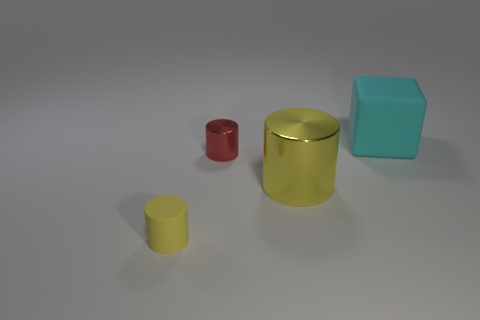Are there more tiny cylinders than objects?
Offer a very short reply. No. Is there anything else that has the same color as the small metallic thing?
Keep it short and to the point. No. Is the big cylinder made of the same material as the small red thing?
Make the answer very short. Yes. Is the number of red cylinders less than the number of small objects?
Keep it short and to the point. Yes. Is the shape of the big yellow metallic thing the same as the small rubber thing?
Ensure brevity in your answer.  Yes. The big rubber cube is what color?
Provide a succinct answer. Cyan. What number of other things are there of the same material as the cube
Provide a succinct answer. 1. How many brown objects are either large cubes or small shiny cylinders?
Give a very brief answer. 0. There is a rubber object left of the big shiny object; is it the same shape as the yellow object behind the tiny yellow cylinder?
Make the answer very short. Yes. Do the big metal thing and the matte thing that is left of the big cyan thing have the same color?
Your answer should be very brief. Yes. 